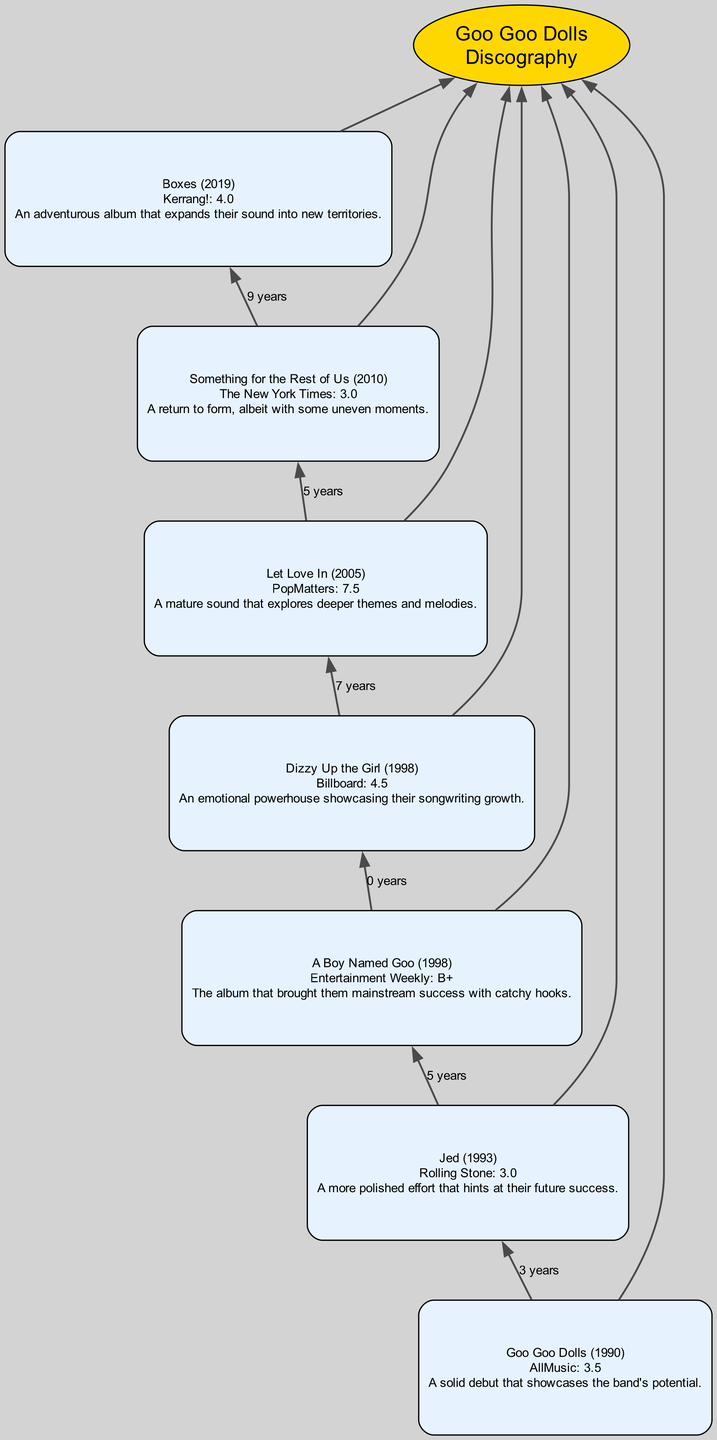What's the rating for "Dizzy Up the Girl"? According to the diagram, the rating for "Dizzy Up the Girl" is 4.5 as provided by Billboard.
Answer: 4.5 What year was "Let Love In" released? The diagram shows that "Let Love In" was released in 2005, as indicated next to the album title.
Answer: 2005 Which critic rated "A Boy Named Goo"? The diagram lists Entertainment Weekly as the critic who reviewed "A Boy Named Goo."
Answer: Entertainment Weekly How many albums received a rating of 3.0? By analyzing the diagram, it can be observed that two albums, "Jed" and "Something for the Rest of Us," both received a rating of 3.0.
Answer: 2 Which album has the highest rating? "Dizzy Up the Girl" is the album with the highest rating of 4.5 based on the information shown in the reviews section of the diagram.
Answer: Dizzy Up the Girl What is the time gap between "Jed" and "A Boy Named Goo"? By examining the release years in the diagram, "Jed" was released in 1993 and "A Boy Named Goo" in 1998. Therefore, the time gap is 5 years.
Answer: 5 years Name the album associated with the critic "Kerrang!" The diagram indicates that "Boxes" is the album associated with the critic Kerrang!
Answer: Boxes Which album's review mentioned "emotional powerhouse"? Upon checking the reviews in the diagram, "Dizzy Up the Girl" contains the phrase "emotional powerhouse" in its review.
Answer: Dizzy Up the Girl Which album was released most recently? The most recent album in the diagram is "Boxes," which was released in 2019, as shown at the bottom of the chart.
Answer: Boxes 